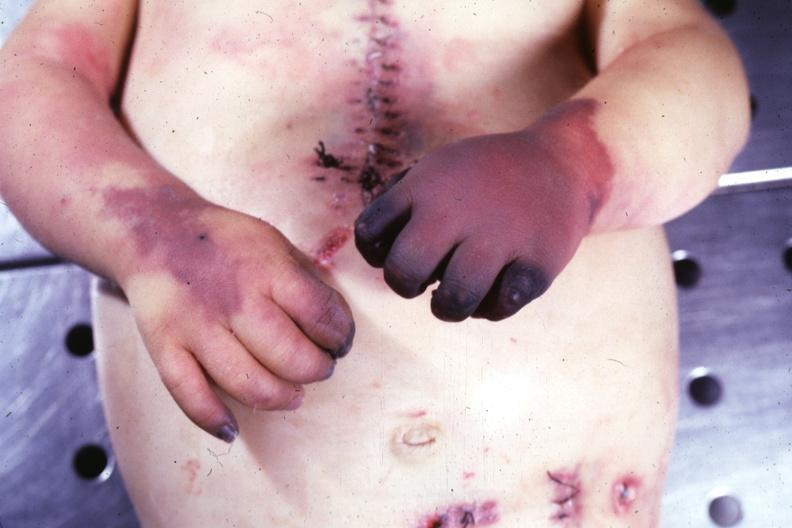why does this image show gangrene both hands?
Answer the question using a single word or phrase. Due to embolism case of av canal with downs syndrome 